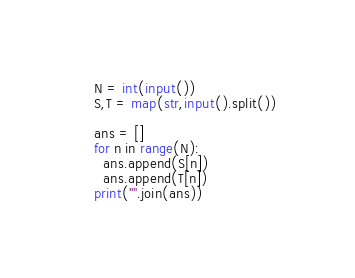<code> <loc_0><loc_0><loc_500><loc_500><_Python_>N = int(input())
S,T = map(str,input().split())

ans = []
for n in range(N):
  ans.append(S[n])
  ans.append(T[n])
print("".join(ans))</code> 